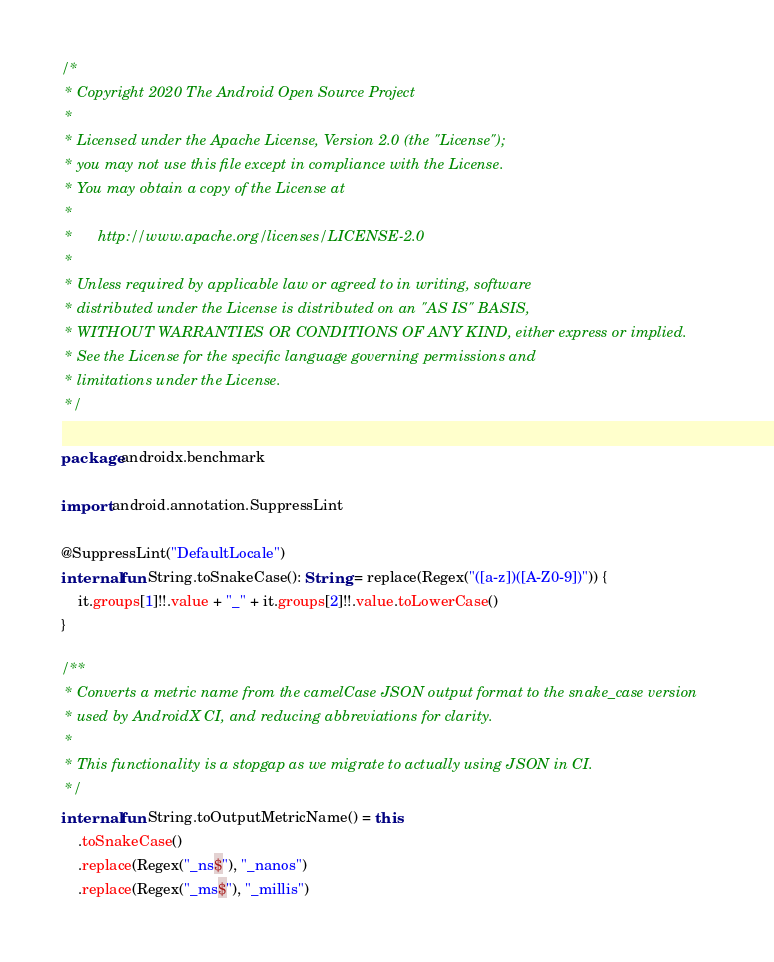<code> <loc_0><loc_0><loc_500><loc_500><_Kotlin_>/*
 * Copyright 2020 The Android Open Source Project
 *
 * Licensed under the Apache License, Version 2.0 (the "License");
 * you may not use this file except in compliance with the License.
 * You may obtain a copy of the License at
 *
 *      http://www.apache.org/licenses/LICENSE-2.0
 *
 * Unless required by applicable law or agreed to in writing, software
 * distributed under the License is distributed on an "AS IS" BASIS,
 * WITHOUT WARRANTIES OR CONDITIONS OF ANY KIND, either express or implied.
 * See the License for the specific language governing permissions and
 * limitations under the License.
 */

package androidx.benchmark

import android.annotation.SuppressLint

@SuppressLint("DefaultLocale")
internal fun String.toSnakeCase(): String = replace(Regex("([a-z])([A-Z0-9])")) {
    it.groups[1]!!.value + "_" + it.groups[2]!!.value.toLowerCase()
}

/**
 * Converts a metric name from the camelCase JSON output format to the snake_case version
 * used by AndroidX CI, and reducing abbreviations for clarity.
 *
 * This functionality is a stopgap as we migrate to actually using JSON in CI.
 */
internal fun String.toOutputMetricName() = this
    .toSnakeCase()
    .replace(Regex("_ns$"), "_nanos")
    .replace(Regex("_ms$"), "_millis")</code> 